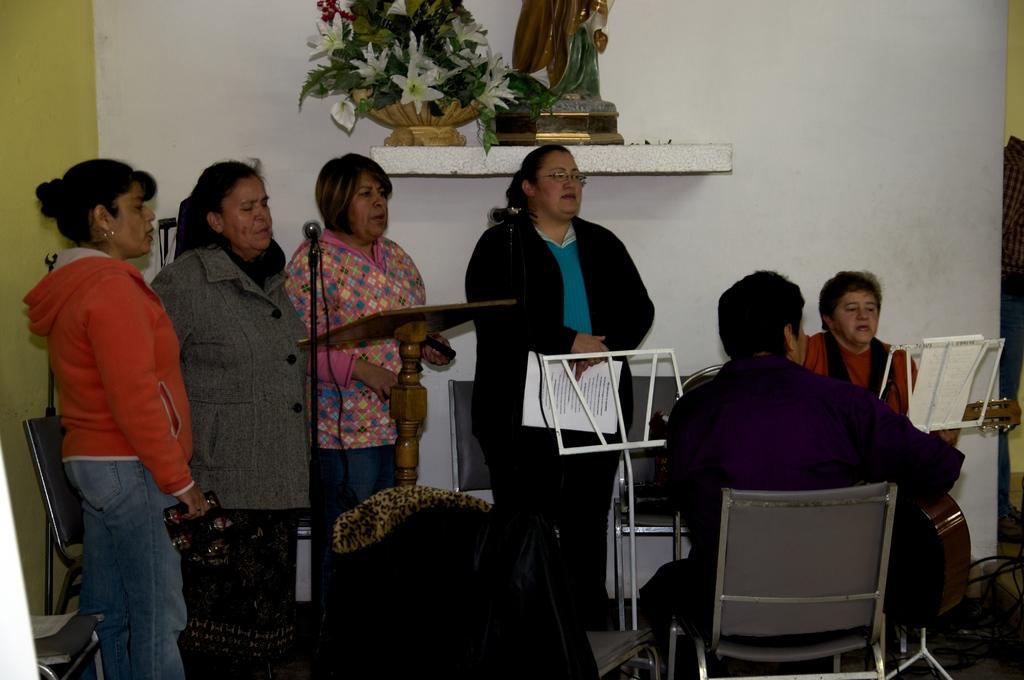Describe this image in one or two sentences. In this image there are group of persons who are singing in front of them there are microphone,tables and a person sitting playing musical instrument and at the top of the image there is a flower vase. 